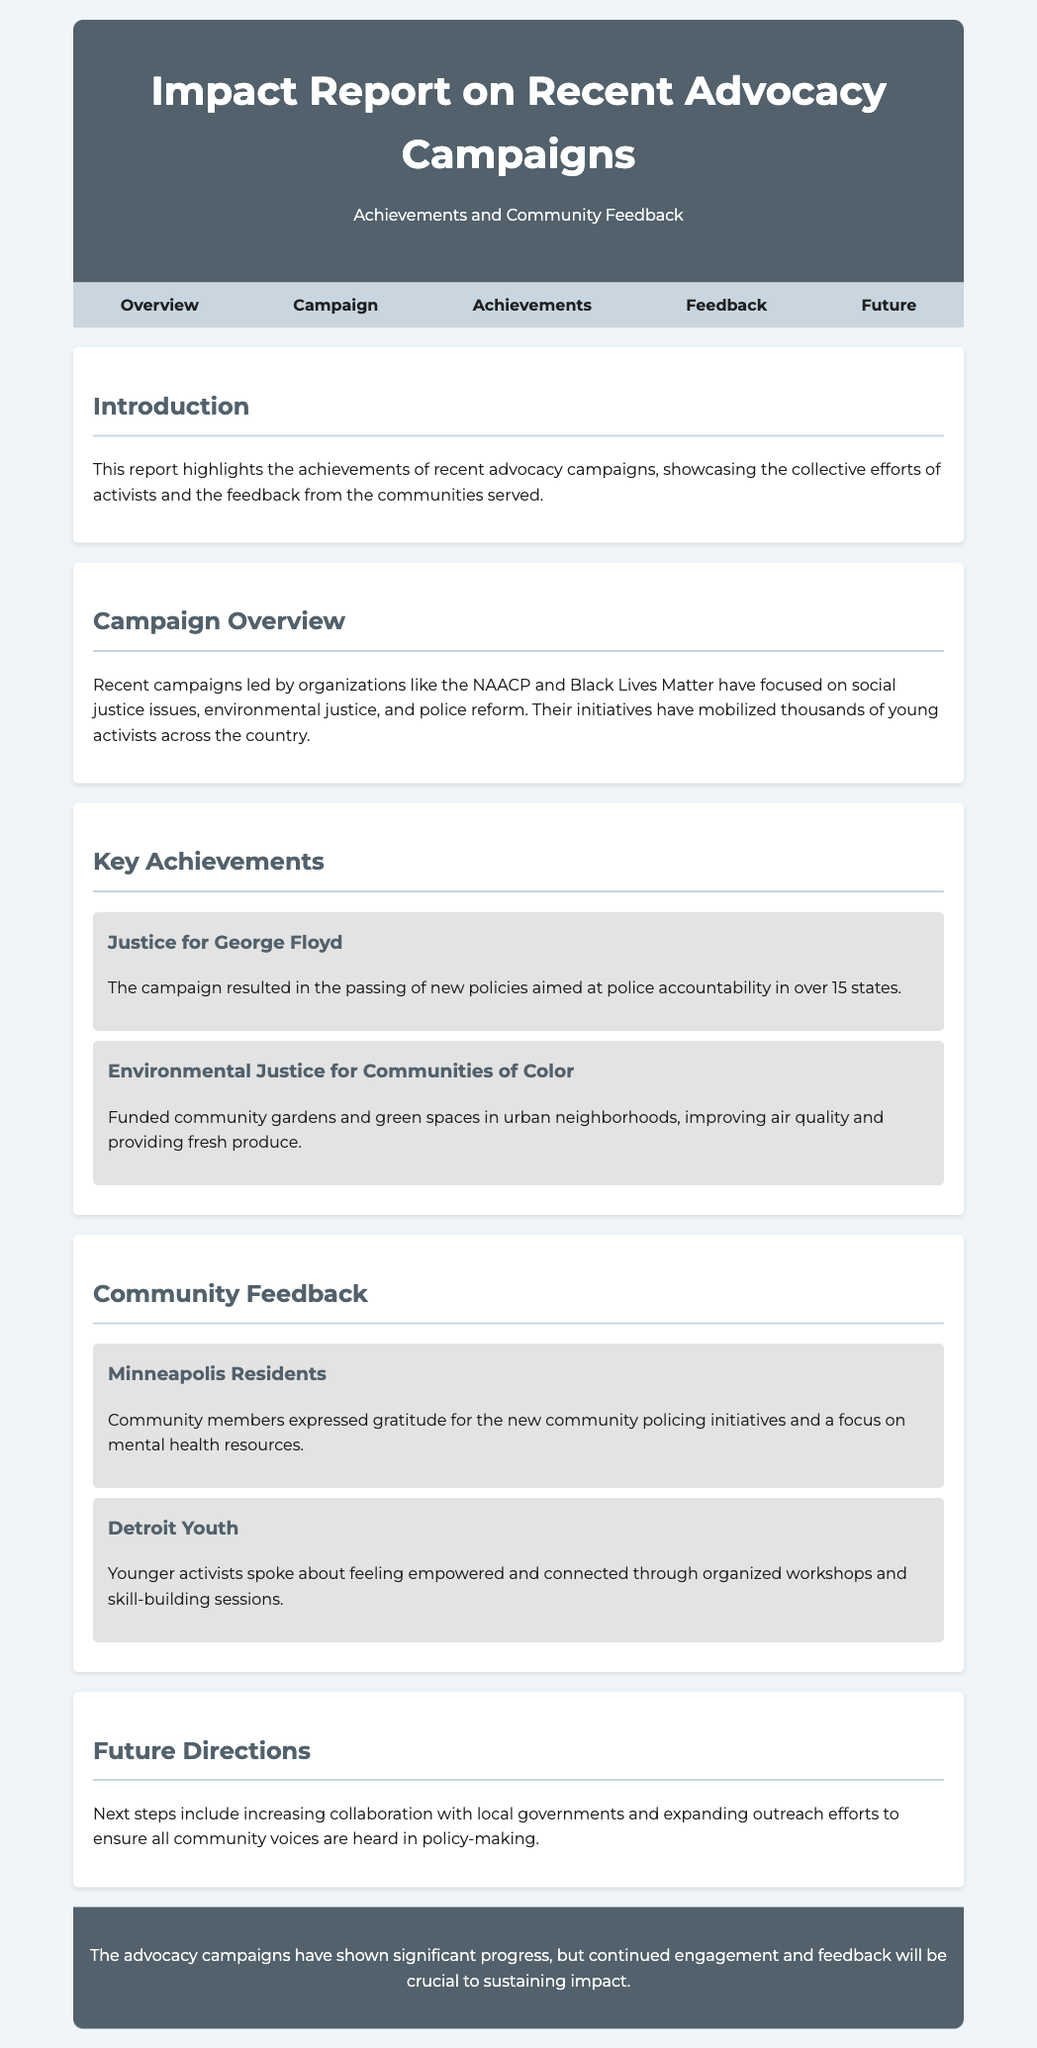what is the title of the report? The title of the report is found in the header section of the document.
Answer: Impact Report on Recent Advocacy Campaigns which organizations led the recent campaigns mentioned? The organizations are listed in the Campaign Overview section of the document.
Answer: NAACP and Black Lives Matter how many states have new policies aimed at police accountability? This information is given in the Key Achievements section of the document.
Answer: over 15 states what community feedback was expressed by Minneapolis residents? The feedback details are presented in the Community Feedback section.
Answer: Gratitude for new community policing initiatives what future direction is mentioned in the report? The future directions are summarized in the Future Directions section of the document.
Answer: Increasing collaboration with local governments what is one of the achievements of the Environmental Justice campaign? The achievement is described in the Key Achievements section.
Answer: Funded community gardens and green spaces how did Detroit youth feel about the organized workshops? This sentiment is expressed in the Community Feedback section.
Answer: Empowered and connected what color scheme is used in the header of the report? The color scheme is referred to in the style section and the visual appearance is described.
Answer: Dark gray and white 